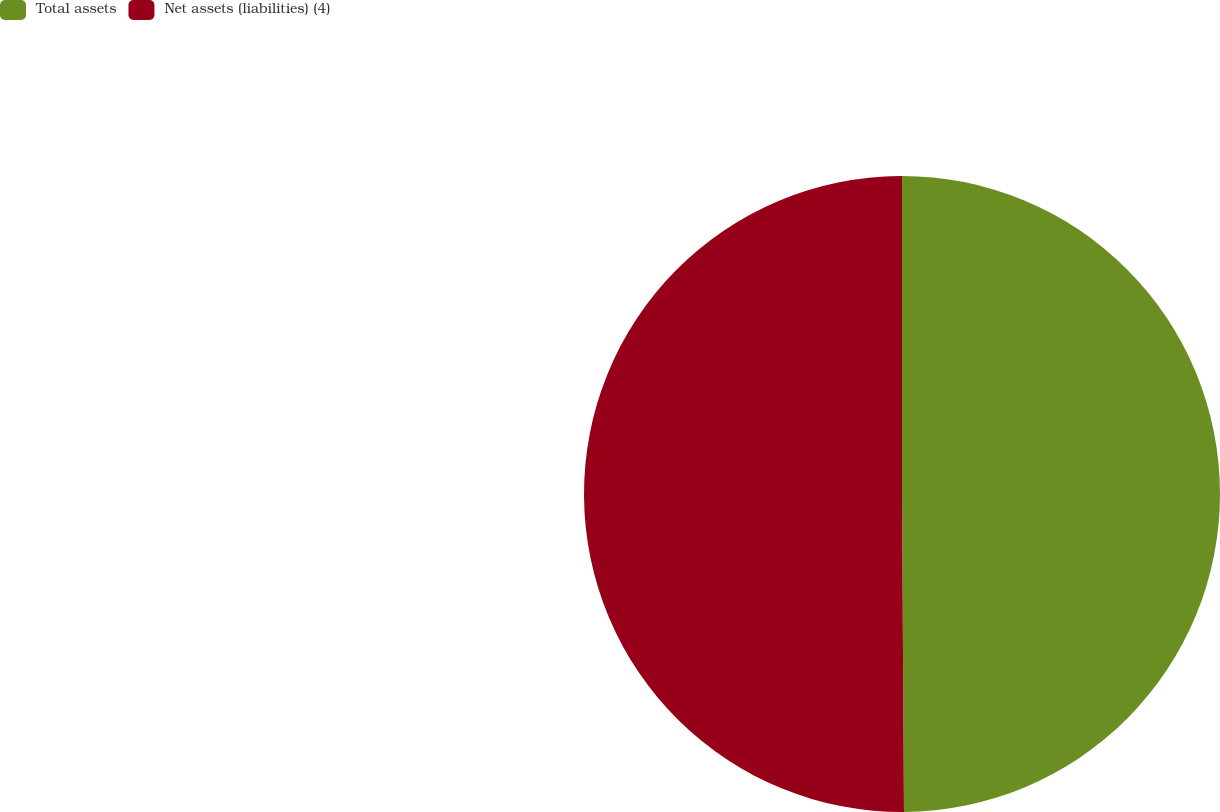Convert chart. <chart><loc_0><loc_0><loc_500><loc_500><pie_chart><fcel>Total assets<fcel>Net assets (liabilities) (4)<nl><fcel>49.9%<fcel>50.1%<nl></chart> 